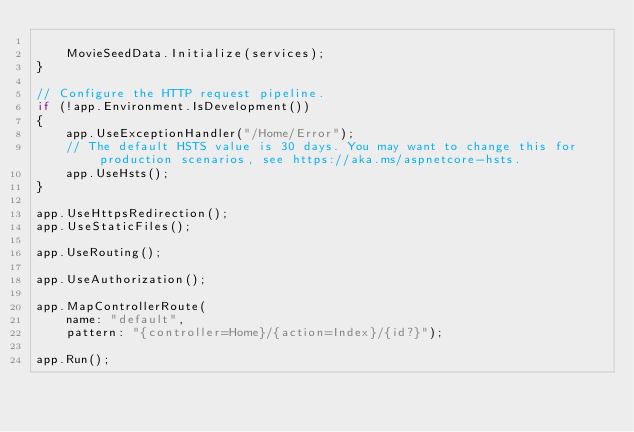Convert code to text. <code><loc_0><loc_0><loc_500><loc_500><_C#_>
    MovieSeedData.Initialize(services);
}

// Configure the HTTP request pipeline.
if (!app.Environment.IsDevelopment())
{
    app.UseExceptionHandler("/Home/Error");
    // The default HSTS value is 30 days. You may want to change this for production scenarios, see https://aka.ms/aspnetcore-hsts.
    app.UseHsts();
}

app.UseHttpsRedirection();
app.UseStaticFiles();

app.UseRouting();

app.UseAuthorization();

app.MapControllerRoute(
    name: "default",
    pattern: "{controller=Home}/{action=Index}/{id?}");

app.Run();
</code> 